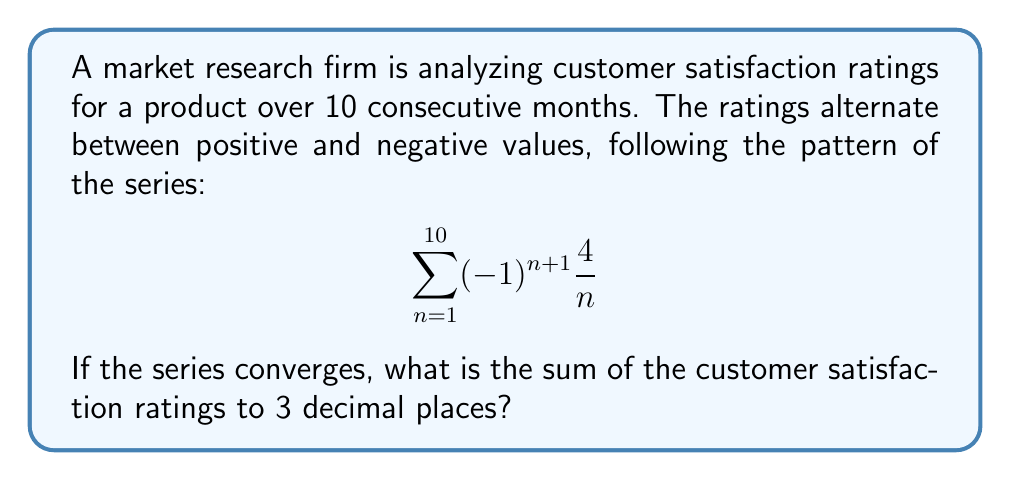Teach me how to tackle this problem. To solve this problem, we'll follow these steps:

1) First, recognize that this is an alternating series of the form:
   $$\sum_{n=1}^{\infty} (-1)^{n+1} \frac{4}{n}$$

2) This series converges by the alternating series test because:
   a) $\lim_{n \to \infty} \frac{4}{n} = 0$
   b) $\frac{4}{n}$ is decreasing for $n \geq 1$

3) For a convergent alternating series, we can use the following formula to find the sum:
   $$S_{\infty} = a_1 - R_1$$
   where $a_1$ is the first term and $R_1$ is the remainder after the first term.

4) In our case, $a_1 = 4$

5) To find $R_1$, we can use the alternating series estimation theorem:
   $|R_n| \leq |a_{n+1}|$

6) So, $|R_1| \leq |a_2| = |-\frac{4}{2}| = 2$

7) Therefore, $2 \leq S_{\infty} \leq 6$

8) We can get a more precise result by calculating more terms:
   $S_{10} = 4 - 2 + \frac{4}{3} - 1 + \frac{4}{5} - \frac{2}{3} + \frac{4}{7} - \frac{1}{2} + \frac{4}{9} - \frac{2}{5}$

9) Calculating this sum:
   $S_{10} \approx 2.928968253968254$

10) Rounding to 3 decimal places:
    $S_{10} \approx 2.929$
Answer: 2.929 